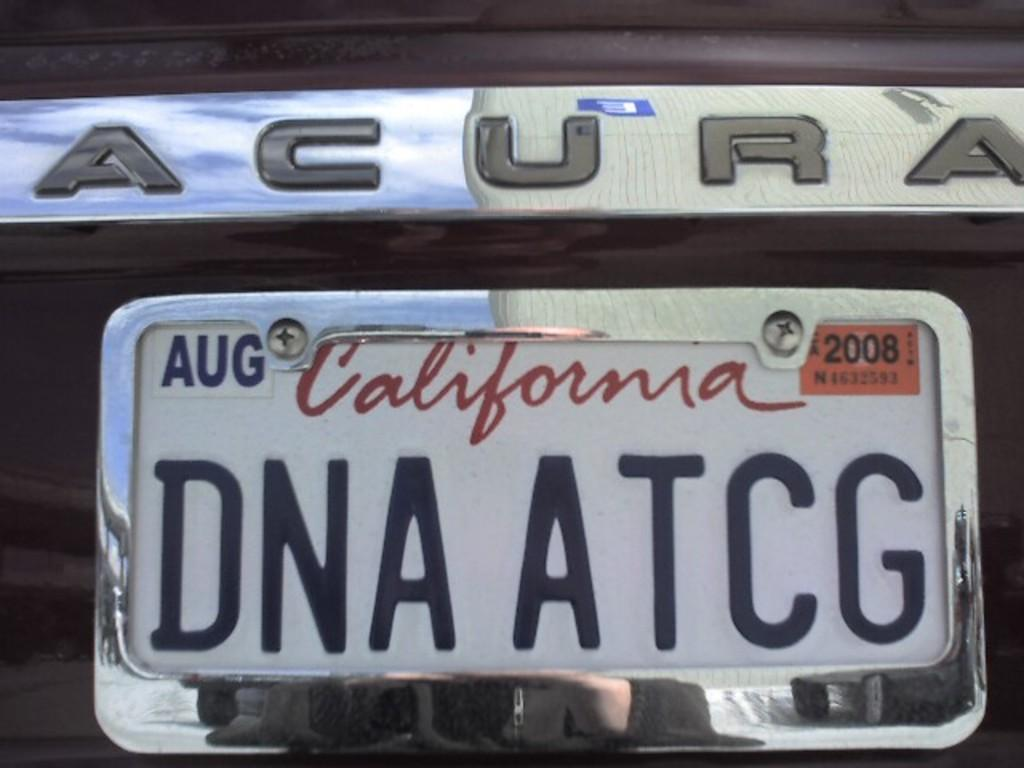<image>
Give a short and clear explanation of the subsequent image. An Acura car with the license plate DNA ATCG. 